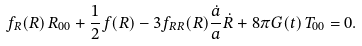<formula> <loc_0><loc_0><loc_500><loc_500>f _ { R } ( R ) \, R _ { 0 0 } + \frac { 1 } { 2 } f ( R ) - 3 f _ { R R } ( R ) \frac { \dot { a } } { a } \dot { R } + 8 \pi G ( t ) \, T _ { 0 0 } = 0 .</formula> 